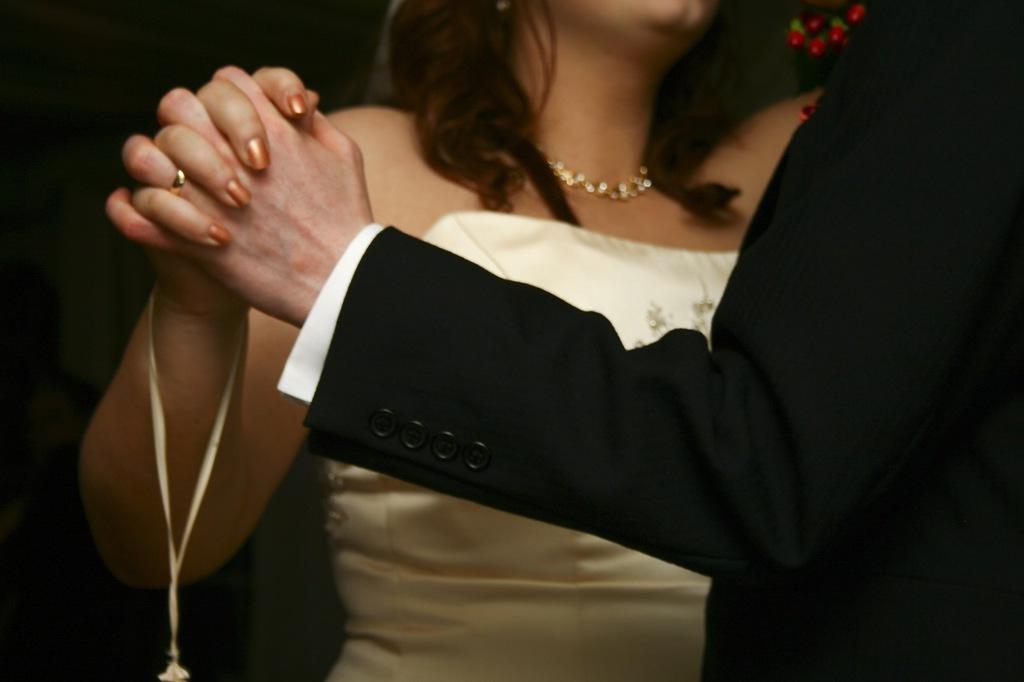How would you summarize this image in a sentence or two? In this image we can see a man and a woman holding their hands. We can also see some flowers. 